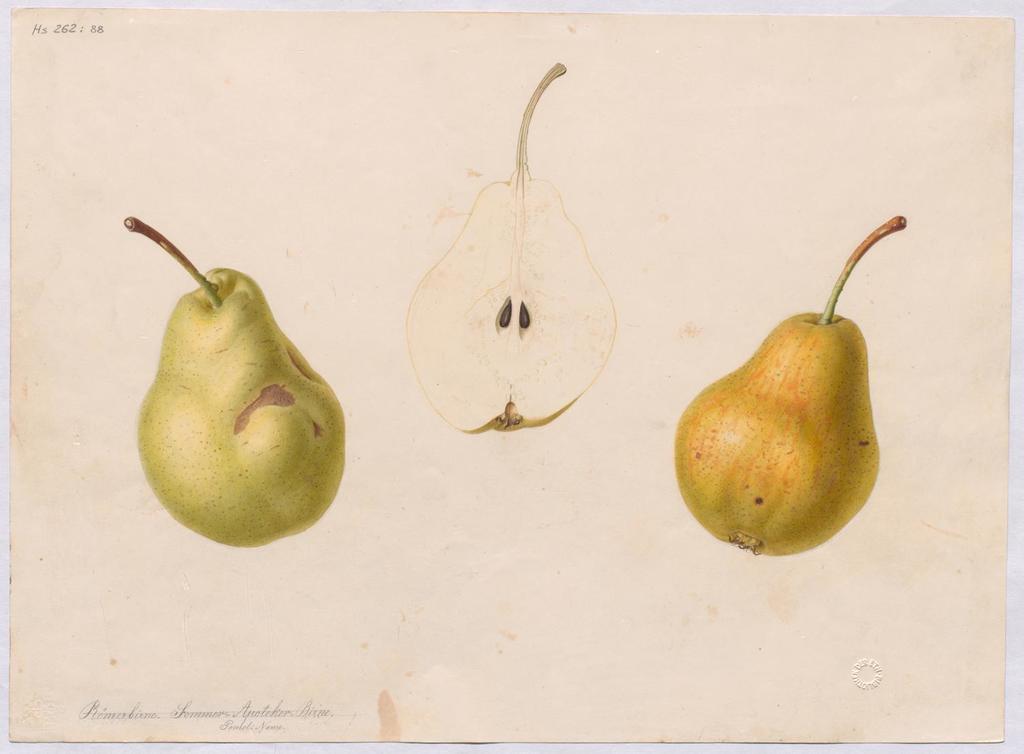Please provide a concise description of this image. In this picture there is a paper, on the paper there are drawings of avocado. At the bottom there is text. 